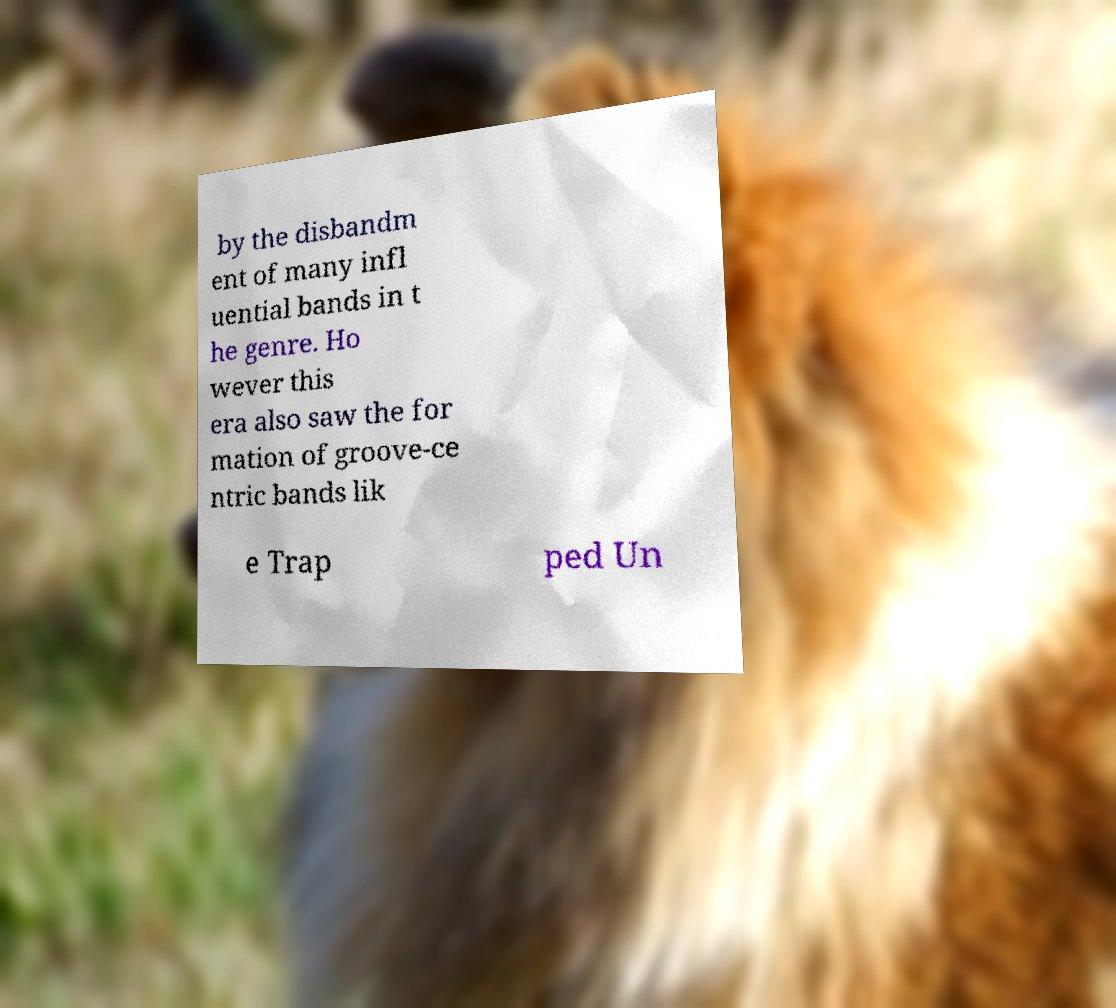Please identify and transcribe the text found in this image. by the disbandm ent of many infl uential bands in t he genre. Ho wever this era also saw the for mation of groove-ce ntric bands lik e Trap ped Un 